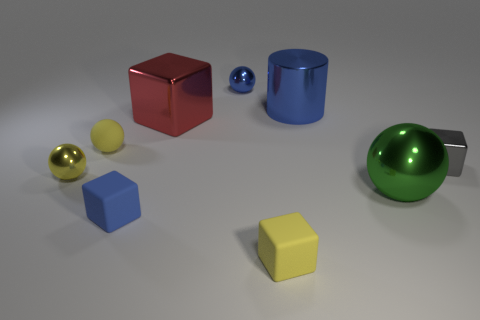Is there anything else that is the same color as the large ball?
Give a very brief answer. No. The tiny metal thing that is behind the tiny gray shiny object is what color?
Your answer should be very brief. Blue. There is a small matte cube right of the red metal object; does it have the same color as the rubber sphere?
Provide a short and direct response. Yes. There is a tiny blue object that is the same shape as the small yellow shiny thing; what is it made of?
Provide a succinct answer. Metal. What number of objects have the same size as the blue block?
Offer a very short reply. 5. What is the shape of the large green metallic thing?
Offer a very short reply. Sphere. How big is the metallic ball that is both in front of the big cylinder and to the left of the tiny yellow rubber cube?
Your response must be concise. Small. There is a blue thing that is right of the yellow cube; what material is it?
Your answer should be very brief. Metal. There is a large shiny cylinder; is it the same color as the block that is behind the small gray cube?
Ensure brevity in your answer.  No. How many objects are either cubes to the left of the big shiny block or yellow cubes on the right side of the blue matte cube?
Provide a succinct answer. 2. 